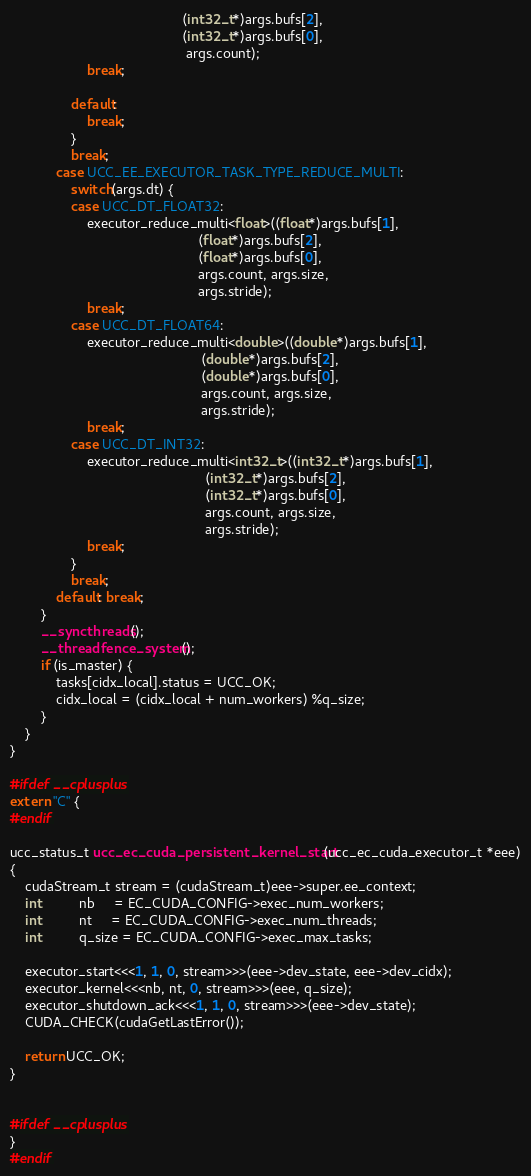Convert code to text. <code><loc_0><loc_0><loc_500><loc_500><_Cuda_>                                             (int32_t*)args.bufs[2],
                                             (int32_t*)args.bufs[0],
                                              args.count);
                    break;

                default:
                    break;
                }
                break;
            case UCC_EE_EXECUTOR_TASK_TYPE_REDUCE_MULTI:
                switch(args.dt) {
                case UCC_DT_FLOAT32:
                    executor_reduce_multi<float>((float*)args.bufs[1],
                                                 (float*)args.bufs[2],
                                                 (float*)args.bufs[0],
                                                 args.count, args.size,
                                                 args.stride);
                    break;
                case UCC_DT_FLOAT64:
                    executor_reduce_multi<double>((double*)args.bufs[1],
                                                  (double*)args.bufs[2],
                                                  (double*)args.bufs[0],
                                                  args.count, args.size,
                                                  args.stride);
                    break;
                case UCC_DT_INT32:
                    executor_reduce_multi<int32_t>((int32_t*)args.bufs[1],
                                                   (int32_t*)args.bufs[2],
                                                   (int32_t*)args.bufs[0],
                                                   args.count, args.size,
                                                   args.stride);
                    break;
                }
                break;
            default: break;
        }
        __syncthreads();
        __threadfence_system();
        if (is_master) {
            tasks[cidx_local].status = UCC_OK;
            cidx_local = (cidx_local + num_workers) %q_size;
        }
    }
}

#ifdef __cplusplus
extern "C" {
#endif

ucc_status_t ucc_ec_cuda_persistent_kernel_start(ucc_ec_cuda_executor_t *eee)
{
    cudaStream_t stream = (cudaStream_t)eee->super.ee_context;
    int          nb     = EC_CUDA_CONFIG->exec_num_workers;
    int          nt     = EC_CUDA_CONFIG->exec_num_threads;
    int          q_size = EC_CUDA_CONFIG->exec_max_tasks;

    executor_start<<<1, 1, 0, stream>>>(eee->dev_state, eee->dev_cidx);
    executor_kernel<<<nb, nt, 0, stream>>>(eee, q_size);
    executor_shutdown_ack<<<1, 1, 0, stream>>>(eee->dev_state);
    CUDA_CHECK(cudaGetLastError());

    return UCC_OK;
}


#ifdef __cplusplus
}
#endif
</code> 